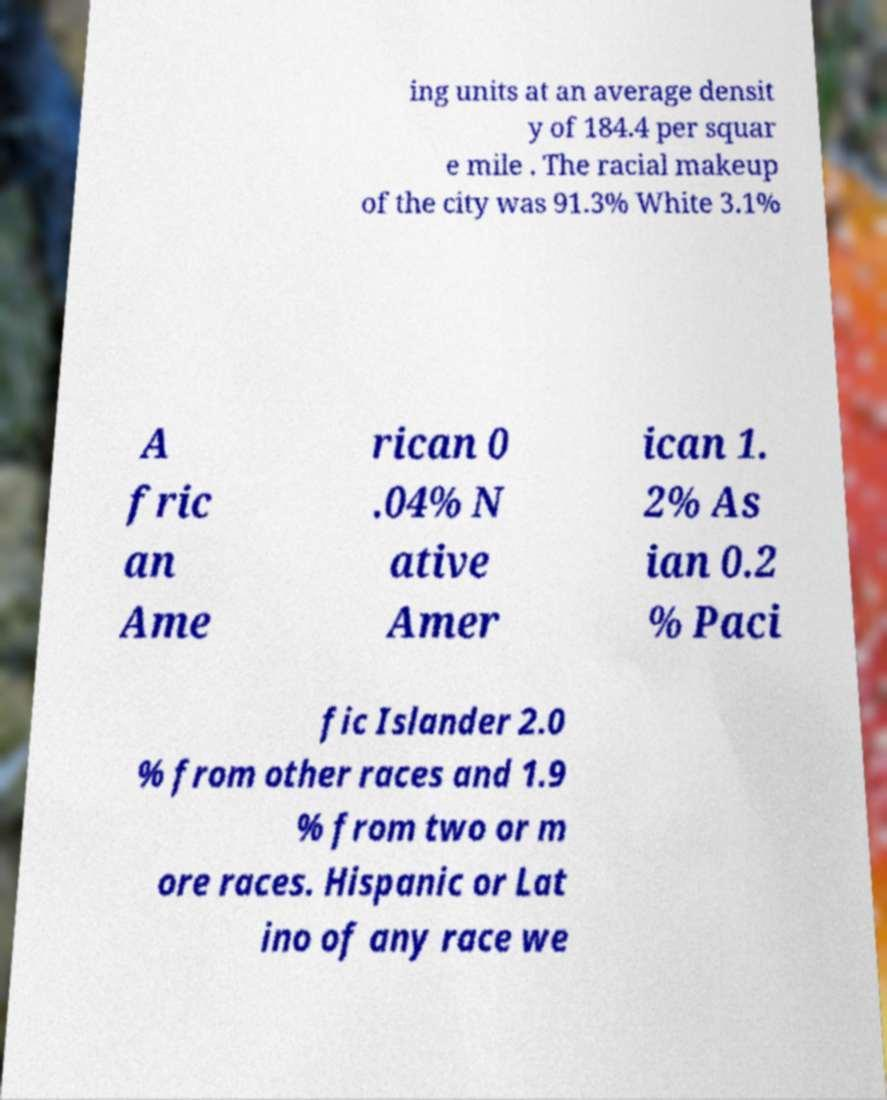There's text embedded in this image that I need extracted. Can you transcribe it verbatim? ing units at an average densit y of 184.4 per squar e mile . The racial makeup of the city was 91.3% White 3.1% A fric an Ame rican 0 .04% N ative Amer ican 1. 2% As ian 0.2 % Paci fic Islander 2.0 % from other races and 1.9 % from two or m ore races. Hispanic or Lat ino of any race we 